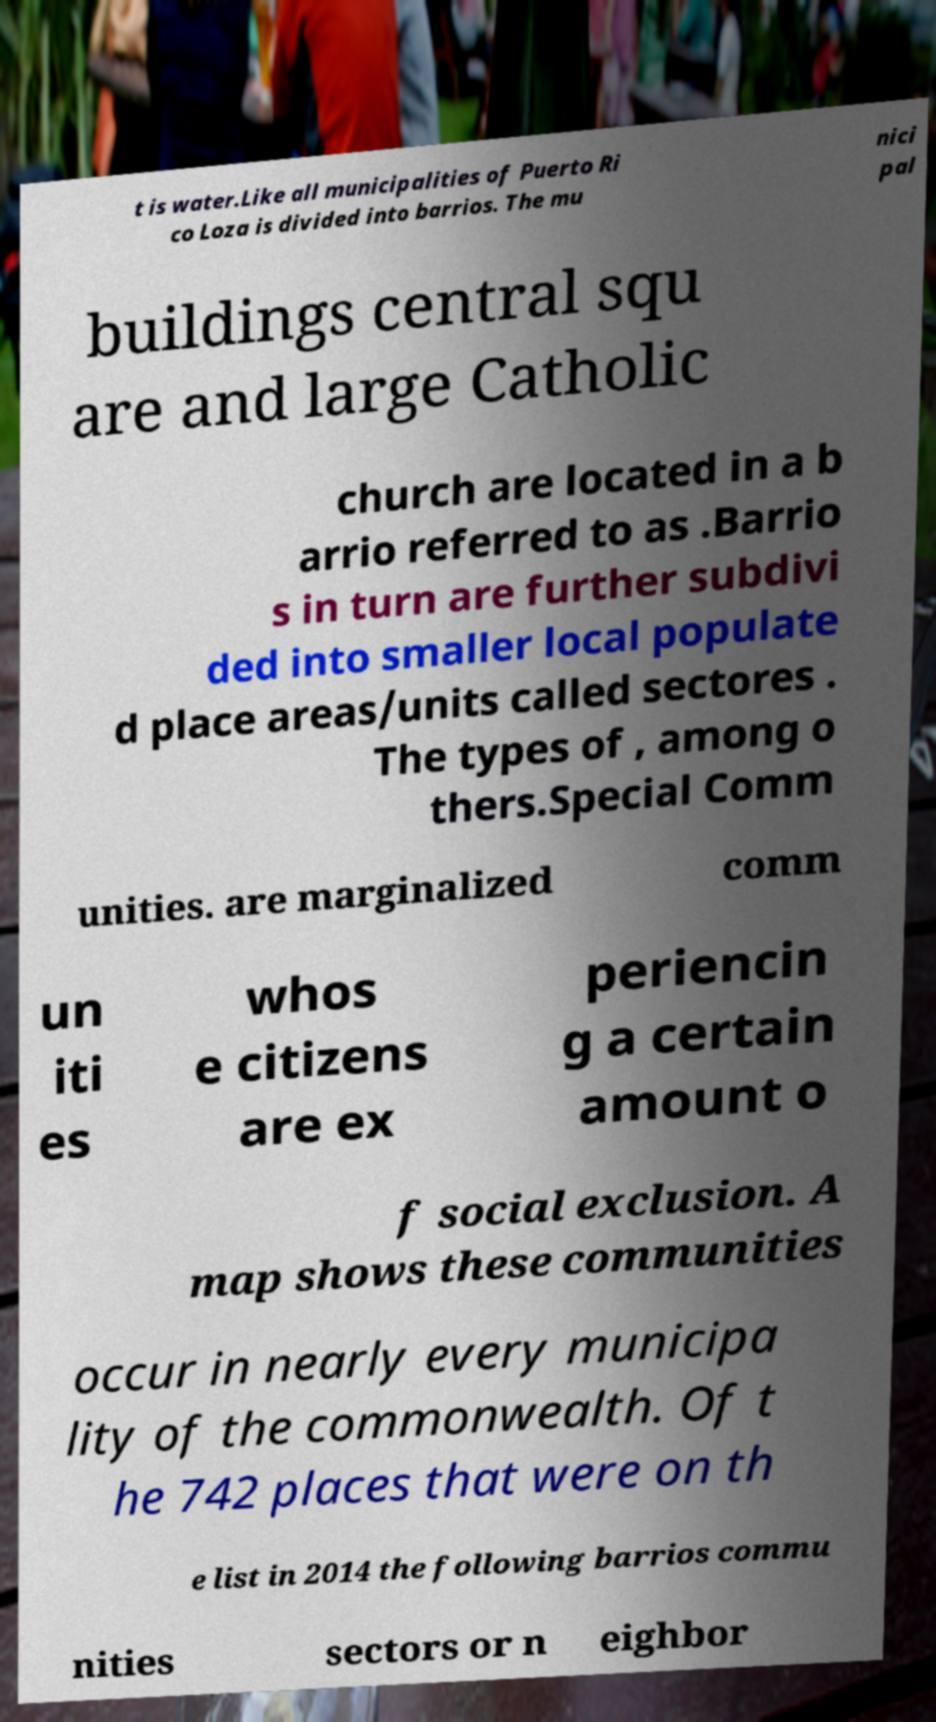I need the written content from this picture converted into text. Can you do that? t is water.Like all municipalities of Puerto Ri co Loza is divided into barrios. The mu nici pal buildings central squ are and large Catholic church are located in a b arrio referred to as .Barrio s in turn are further subdivi ded into smaller local populate d place areas/units called sectores . The types of , among o thers.Special Comm unities. are marginalized comm un iti es whos e citizens are ex periencin g a certain amount o f social exclusion. A map shows these communities occur in nearly every municipa lity of the commonwealth. Of t he 742 places that were on th e list in 2014 the following barrios commu nities sectors or n eighbor 